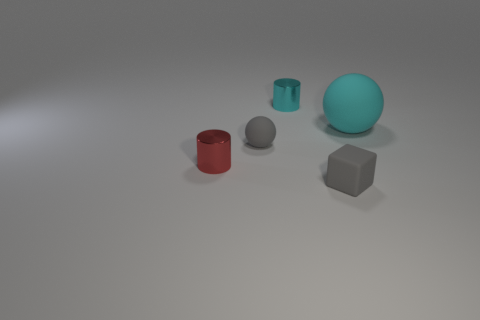Add 2 red matte objects. How many objects exist? 7 Subtract all cyan spheres. How many spheres are left? 1 Subtract all cylinders. How many objects are left? 3 Subtract 2 spheres. How many spheres are left? 0 Subtract all green cylinders. How many cyan balls are left? 1 Add 1 small cyan shiny things. How many small cyan shiny things exist? 2 Subtract 1 red cylinders. How many objects are left? 4 Subtract all cyan cylinders. Subtract all green blocks. How many cylinders are left? 1 Subtract all tiny gray cylinders. Subtract all big cyan things. How many objects are left? 4 Add 3 large matte balls. How many large matte balls are left? 4 